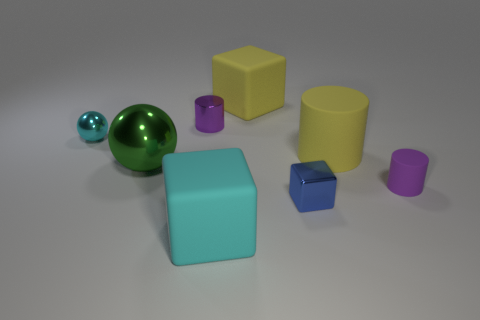Subtract all metallic blocks. How many blocks are left? 2 Subtract 1 blocks. How many blocks are left? 2 Add 1 big things. How many objects exist? 9 Subtract all cyan balls. How many balls are left? 1 Subtract 0 brown cylinders. How many objects are left? 8 Subtract all balls. How many objects are left? 6 Subtract all gray cubes. Subtract all yellow spheres. How many cubes are left? 3 Subtract all gray balls. How many cyan blocks are left? 1 Subtract all metal objects. Subtract all big cyan things. How many objects are left? 3 Add 4 purple metallic cylinders. How many purple metallic cylinders are left? 5 